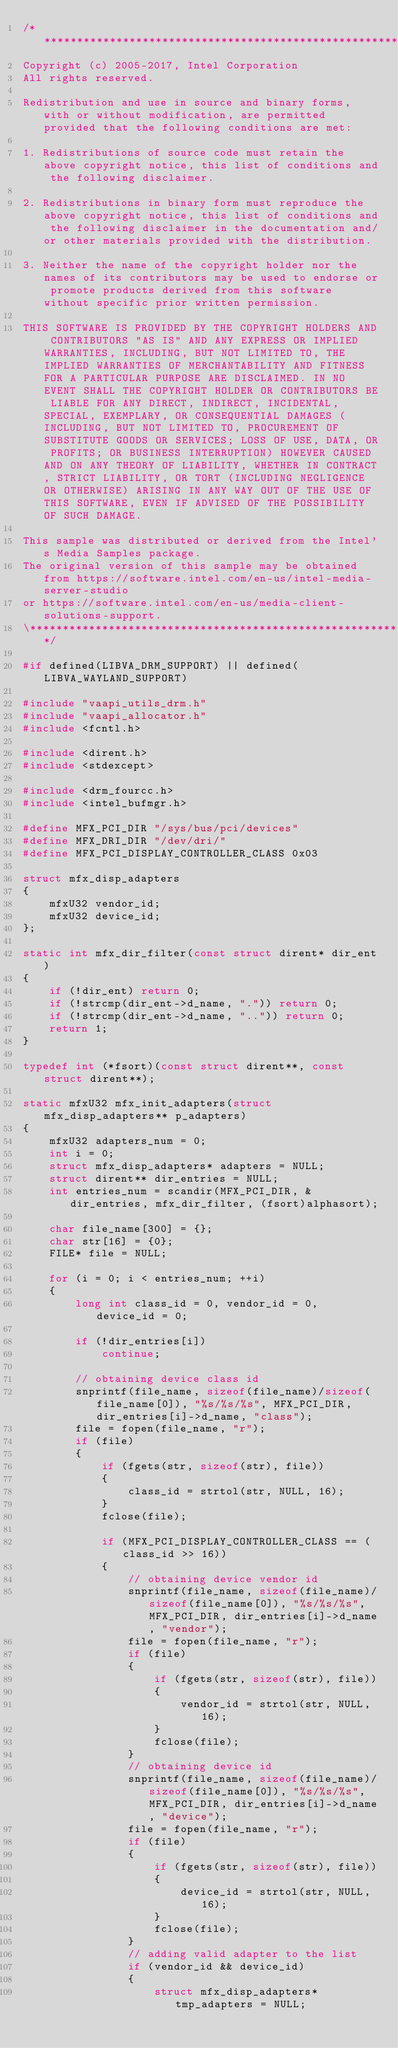Convert code to text. <code><loc_0><loc_0><loc_500><loc_500><_C++_>/******************************************************************************\
Copyright (c) 2005-2017, Intel Corporation
All rights reserved.

Redistribution and use in source and binary forms, with or without modification, are permitted provided that the following conditions are met:

1. Redistributions of source code must retain the above copyright notice, this list of conditions and the following disclaimer.

2. Redistributions in binary form must reproduce the above copyright notice, this list of conditions and the following disclaimer in the documentation and/or other materials provided with the distribution.

3. Neither the name of the copyright holder nor the names of its contributors may be used to endorse or promote products derived from this software without specific prior written permission.

THIS SOFTWARE IS PROVIDED BY THE COPYRIGHT HOLDERS AND CONTRIBUTORS "AS IS" AND ANY EXPRESS OR IMPLIED WARRANTIES, INCLUDING, BUT NOT LIMITED TO, THE IMPLIED WARRANTIES OF MERCHANTABILITY AND FITNESS FOR A PARTICULAR PURPOSE ARE DISCLAIMED. IN NO EVENT SHALL THE COPYRIGHT HOLDER OR CONTRIBUTORS BE LIABLE FOR ANY DIRECT, INDIRECT, INCIDENTAL, SPECIAL, EXEMPLARY, OR CONSEQUENTIAL DAMAGES (INCLUDING, BUT NOT LIMITED TO, PROCUREMENT OF SUBSTITUTE GOODS OR SERVICES; LOSS OF USE, DATA, OR PROFITS; OR BUSINESS INTERRUPTION) HOWEVER CAUSED AND ON ANY THEORY OF LIABILITY, WHETHER IN CONTRACT, STRICT LIABILITY, OR TORT (INCLUDING NEGLIGENCE OR OTHERWISE) ARISING IN ANY WAY OUT OF THE USE OF THIS SOFTWARE, EVEN IF ADVISED OF THE POSSIBILITY OF SUCH DAMAGE.

This sample was distributed or derived from the Intel's Media Samples package.
The original version of this sample may be obtained from https://software.intel.com/en-us/intel-media-server-studio
or https://software.intel.com/en-us/media-client-solutions-support.
\**********************************************************************************/

#if defined(LIBVA_DRM_SUPPORT) || defined(LIBVA_WAYLAND_SUPPORT)

#include "vaapi_utils_drm.h"
#include "vaapi_allocator.h"
#include <fcntl.h>

#include <dirent.h>
#include <stdexcept>

#include <drm_fourcc.h>
#include <intel_bufmgr.h>

#define MFX_PCI_DIR "/sys/bus/pci/devices"
#define MFX_DRI_DIR "/dev/dri/"
#define MFX_PCI_DISPLAY_CONTROLLER_CLASS 0x03

struct mfx_disp_adapters
{
    mfxU32 vendor_id;
    mfxU32 device_id;
};

static int mfx_dir_filter(const struct dirent* dir_ent)
{
    if (!dir_ent) return 0;
    if (!strcmp(dir_ent->d_name, ".")) return 0;
    if (!strcmp(dir_ent->d_name, "..")) return 0;
    return 1;
}

typedef int (*fsort)(const struct dirent**, const struct dirent**);

static mfxU32 mfx_init_adapters(struct mfx_disp_adapters** p_adapters)
{
    mfxU32 adapters_num = 0;
    int i = 0;
    struct mfx_disp_adapters* adapters = NULL;
    struct dirent** dir_entries = NULL;
    int entries_num = scandir(MFX_PCI_DIR, &dir_entries, mfx_dir_filter, (fsort)alphasort);

    char file_name[300] = {};
    char str[16] = {0};
    FILE* file = NULL;

    for (i = 0; i < entries_num; ++i)
    {
        long int class_id = 0, vendor_id = 0, device_id = 0;

        if (!dir_entries[i])
            continue;

        // obtaining device class id
        snprintf(file_name, sizeof(file_name)/sizeof(file_name[0]), "%s/%s/%s", MFX_PCI_DIR, dir_entries[i]->d_name, "class");
        file = fopen(file_name, "r");
        if (file)
        {
            if (fgets(str, sizeof(str), file))
            {
                class_id = strtol(str, NULL, 16);
            }
            fclose(file);

            if (MFX_PCI_DISPLAY_CONTROLLER_CLASS == (class_id >> 16))
            {
                // obtaining device vendor id
                snprintf(file_name, sizeof(file_name)/sizeof(file_name[0]), "%s/%s/%s", MFX_PCI_DIR, dir_entries[i]->d_name, "vendor");
                file = fopen(file_name, "r");
                if (file)
                {
                    if (fgets(str, sizeof(str), file))
                    {
                        vendor_id = strtol(str, NULL, 16);
                    }
                    fclose(file);
                }
                // obtaining device id
                snprintf(file_name, sizeof(file_name)/sizeof(file_name[0]), "%s/%s/%s", MFX_PCI_DIR, dir_entries[i]->d_name, "device");
                file = fopen(file_name, "r");
                if (file)
                {
                    if (fgets(str, sizeof(str), file))
                    {
                        device_id = strtol(str, NULL, 16);
                    }
                    fclose(file);
                }
                // adding valid adapter to the list
                if (vendor_id && device_id)
                {
                    struct mfx_disp_adapters* tmp_adapters = NULL;
</code> 